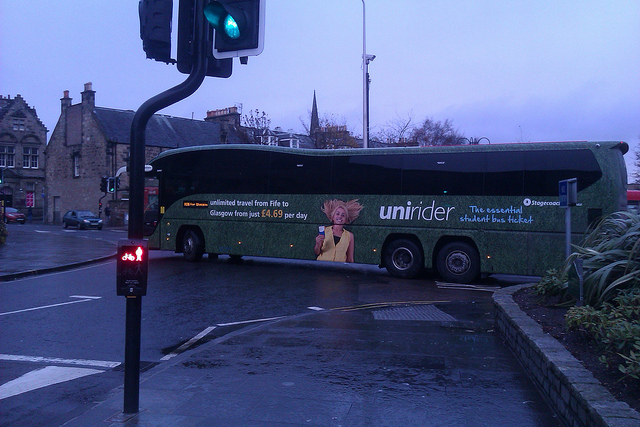Based on the vehicles' positions, can you infer which country or region this might be in? The vehicles are driving on the left side of the road, which is characteristic of countries such as the UK and Australia. Given the promotional details on the bus, specifically mentioning 'Fife to Glasgow,' it strongly suggests that this scene is in Scotland, UK. 